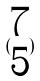Convert formula to latex. <formula><loc_0><loc_0><loc_500><loc_500>( \begin{matrix} 7 \\ 5 \end{matrix} )</formula> 